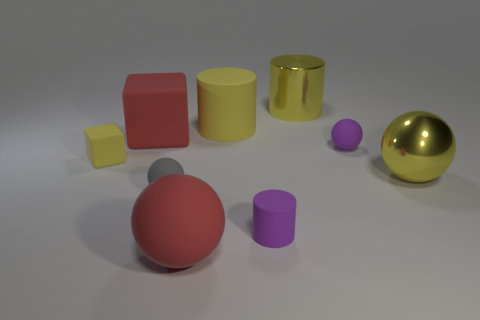What size is the cube that is the same color as the metal sphere? small 